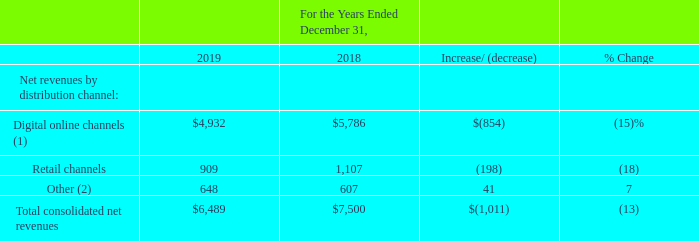Consolidated Results
Net Revenues by Distribution Channel
The following table details our consolidated net revenues by distribution channel (amounts in millions):
(1) Net revenues from “Digital online channels” include revenues from digitally-distributed subscriptions, downloadable content, microtransactions, and products, as well as licensing royalties.
(2) Net revenues from “Other” primarily includes revenues from our Distribution business and the Overwatch League.
Digital Online Channel Net Revenues The decrease in net revenues from digital online channels for 2019, as compared to 2018, was primarily due to: • lower revenues recognized from the Destiny franchise (reflecting our sale of the publishing rights for Destiny to Bungie in December 2018); and • lower revenues recognized from Hearthstone.
Retail Channel Net Revenues The decrease in net revenues from retail channels for 2019, as compared to 2018, was primarily due to: • lower revenues recognized from Call of Duty: Black Ops 4, which was released in October 2018, as compared to Call of Duty: WWII, which was released in November 2017; • lower revenues recognized from the Destiny franchise; and • lower revenues from Crash Bandicoot™ N. Sane Trilogy, which was released on the Xbox One, PC, and Nintendo Switch in June 2018.
The decrease was partially offset by: • revenues recognized from Crash Team Racing Nitro-Fueled, which was released in June 2019; • revenues from Sekiro: Shadows Die Twice, which was released in March 2019; and • higher revenues recognized from Call of Duty: Modern Warfare, which was released in October 2019, as compared to Call of Duty: Black Ops 4.
What does Net revenues from “Digital online channels” include? Revenues from digitally-distributed subscriptions, downloadable content, microtransactions, and products, as well as licensing royalties. What does Net revenues from “Other” include? Revenues from our distribution business and the overwatch league. What was net revenues from retail channels in 2019?
Answer scale should be: million. 909. What is the total consolidated net revenue of Digital Online channels and Other in 2019?
Answer scale should be: million. $4,932+648
Answer: 5580. What is the total consolidated net revenue of Digital Online channels and Other in 2018?
Answer scale should be: million. $5,786+607
Answer: 6393. What percentage of total consolidated net revenue consists of Other in 2019?
Answer scale should be: percent. (648/$6,489)
Answer: 9.99. 